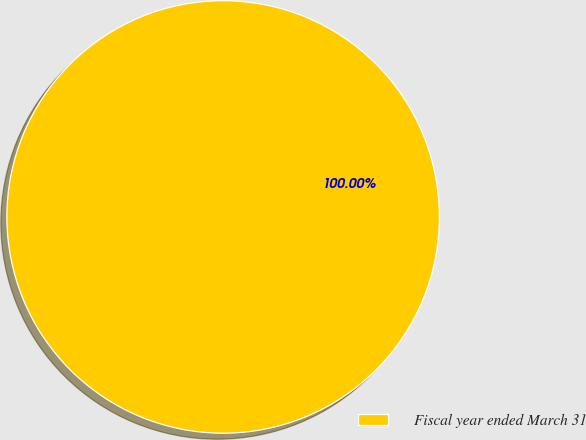Convert chart. <chart><loc_0><loc_0><loc_500><loc_500><pie_chart><fcel>Fiscal year ended March 31<nl><fcel>100.0%<nl></chart> 